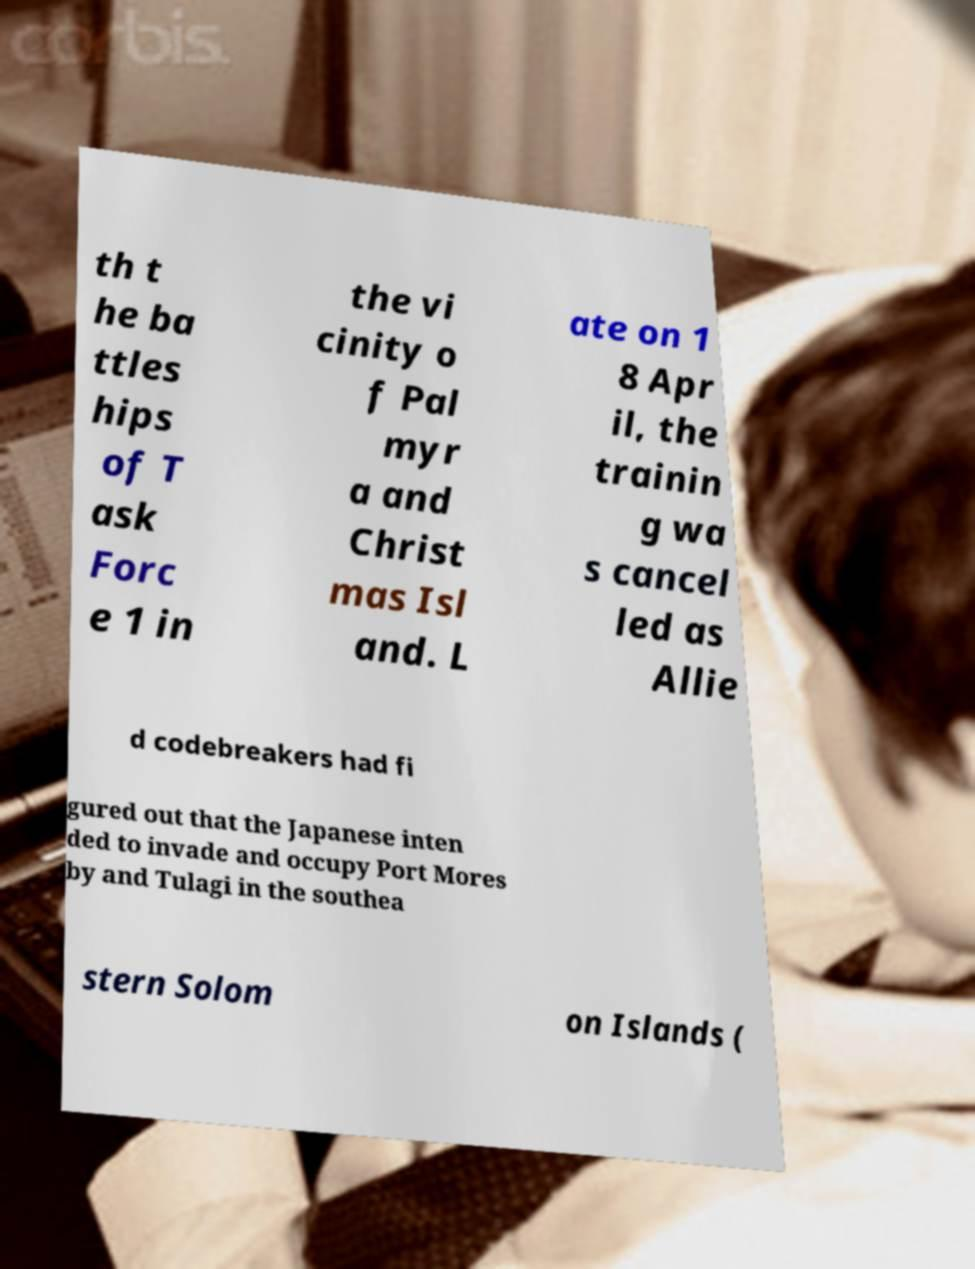Please read and relay the text visible in this image. What does it say? th t he ba ttles hips of T ask Forc e 1 in the vi cinity o f Pal myr a and Christ mas Isl and. L ate on 1 8 Apr il, the trainin g wa s cancel led as Allie d codebreakers had fi gured out that the Japanese inten ded to invade and occupy Port Mores by and Tulagi in the southea stern Solom on Islands ( 